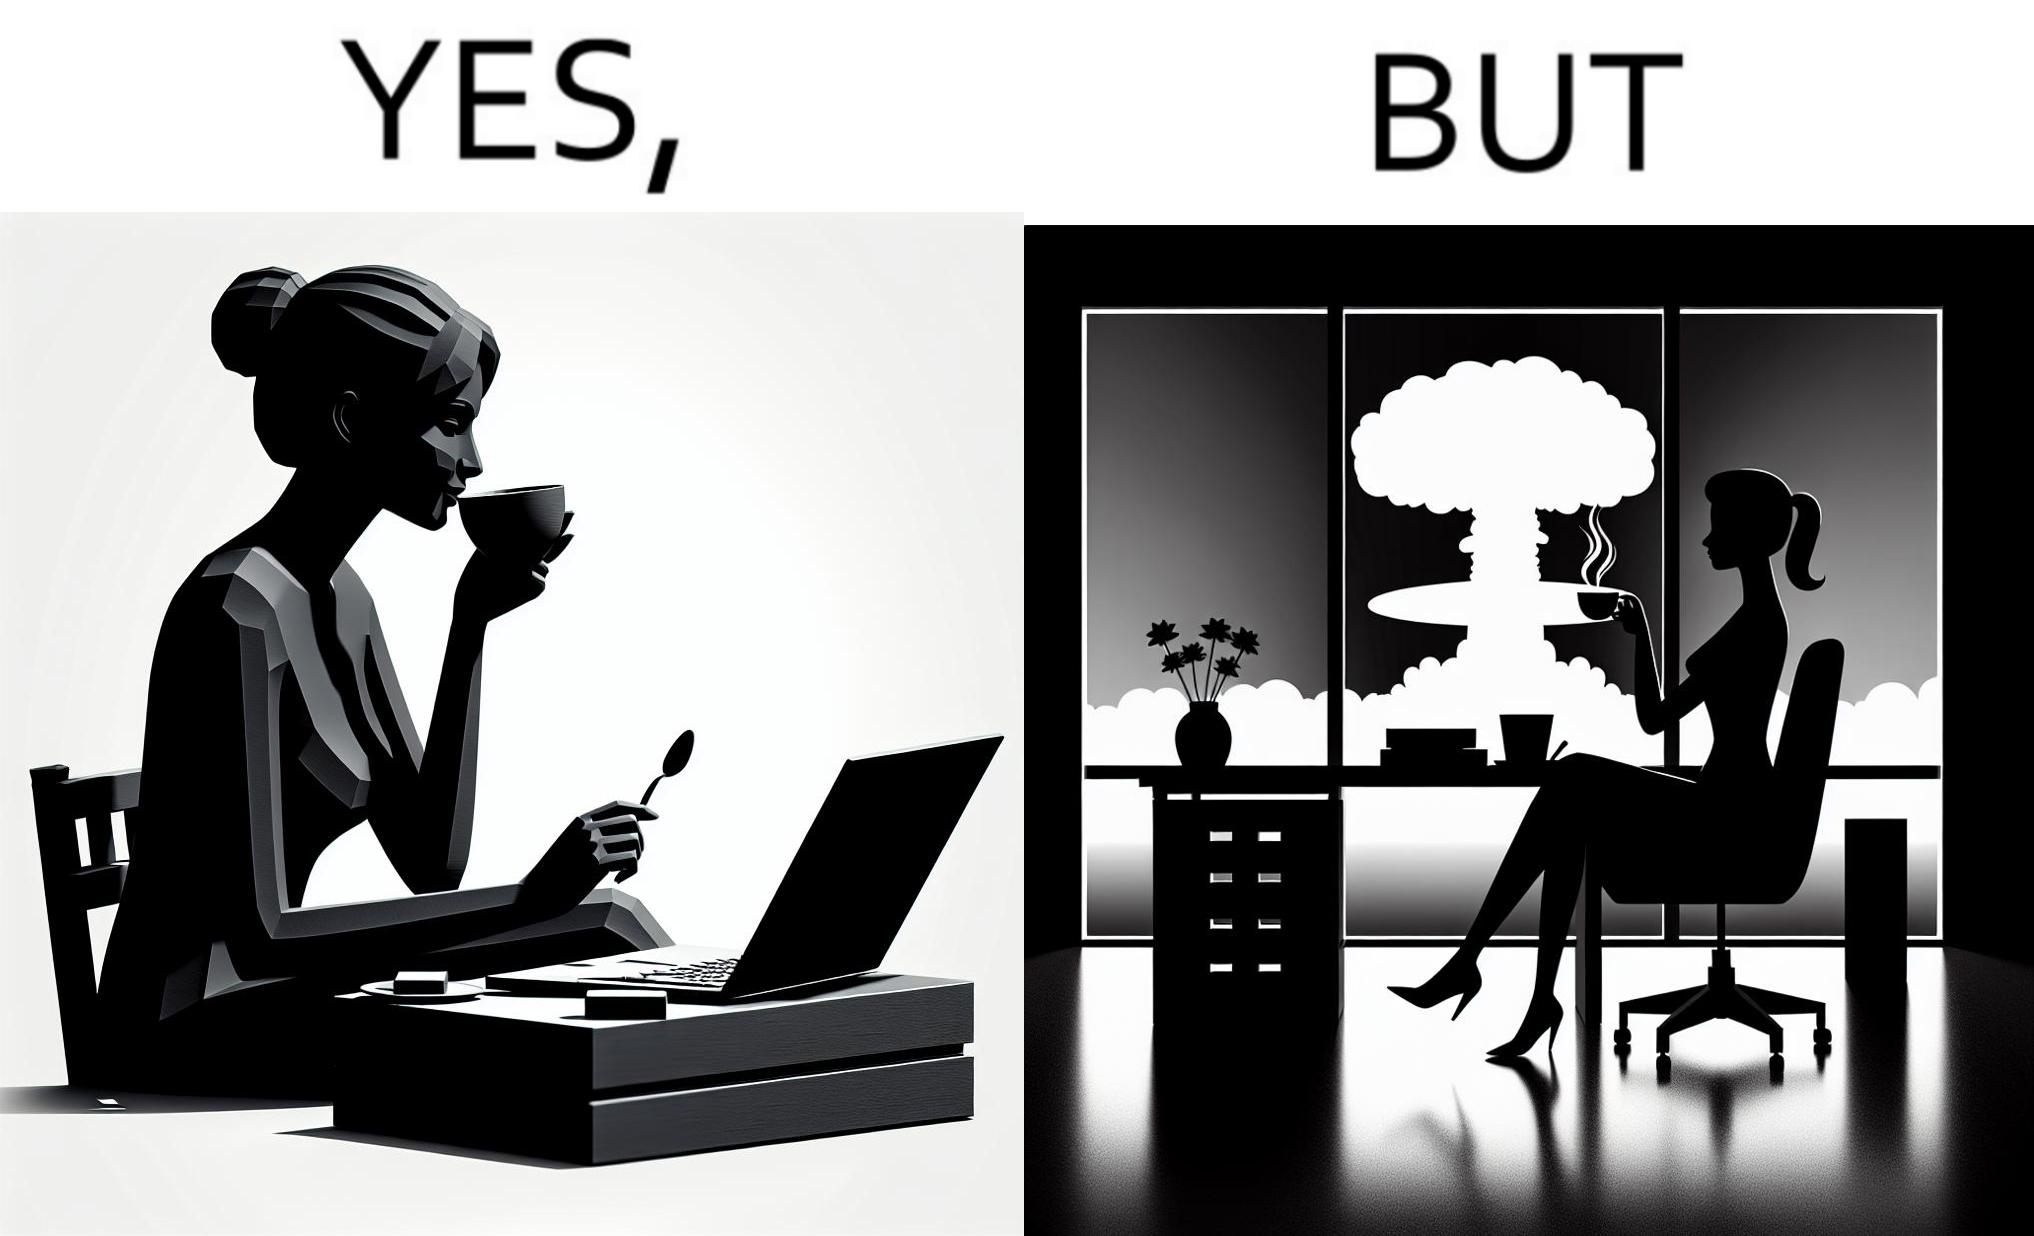What does this image depict? The images are funny since it shows a woman simply sipping from a cup at ease in a cafe with her laptop not caring about anything going on outside the cafe even though the situation is very grave,that is, a nuclear blast 